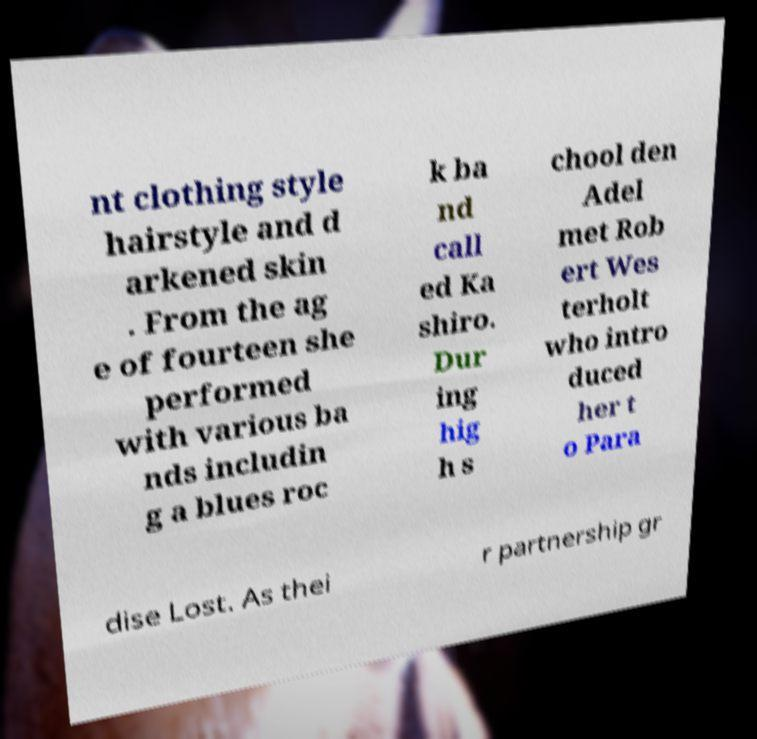Can you accurately transcribe the text from the provided image for me? nt clothing style hairstyle and d arkened skin . From the ag e of fourteen she performed with various ba nds includin g a blues roc k ba nd call ed Ka shiro. Dur ing hig h s chool den Adel met Rob ert Wes terholt who intro duced her t o Para dise Lost. As thei r partnership gr 